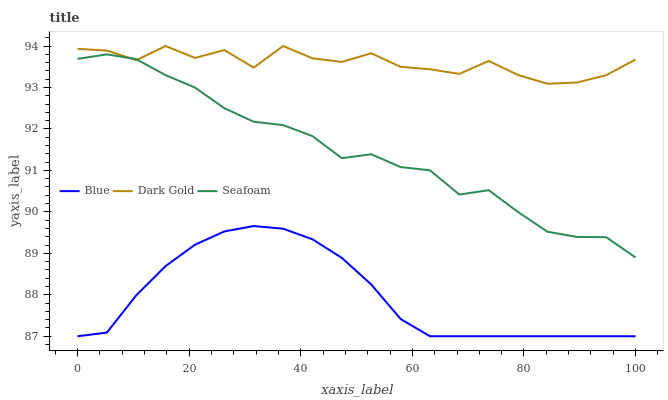Does Blue have the minimum area under the curve?
Answer yes or no. Yes. Does Dark Gold have the maximum area under the curve?
Answer yes or no. Yes. Does Seafoam have the minimum area under the curve?
Answer yes or no. No. Does Seafoam have the maximum area under the curve?
Answer yes or no. No. Is Blue the smoothest?
Answer yes or no. Yes. Is Dark Gold the roughest?
Answer yes or no. Yes. Is Seafoam the smoothest?
Answer yes or no. No. Is Seafoam the roughest?
Answer yes or no. No. Does Blue have the lowest value?
Answer yes or no. Yes. Does Seafoam have the lowest value?
Answer yes or no. No. Does Dark Gold have the highest value?
Answer yes or no. Yes. Does Seafoam have the highest value?
Answer yes or no. No. Is Blue less than Dark Gold?
Answer yes or no. Yes. Is Seafoam greater than Blue?
Answer yes or no. Yes. Does Dark Gold intersect Seafoam?
Answer yes or no. Yes. Is Dark Gold less than Seafoam?
Answer yes or no. No. Is Dark Gold greater than Seafoam?
Answer yes or no. No. Does Blue intersect Dark Gold?
Answer yes or no. No. 